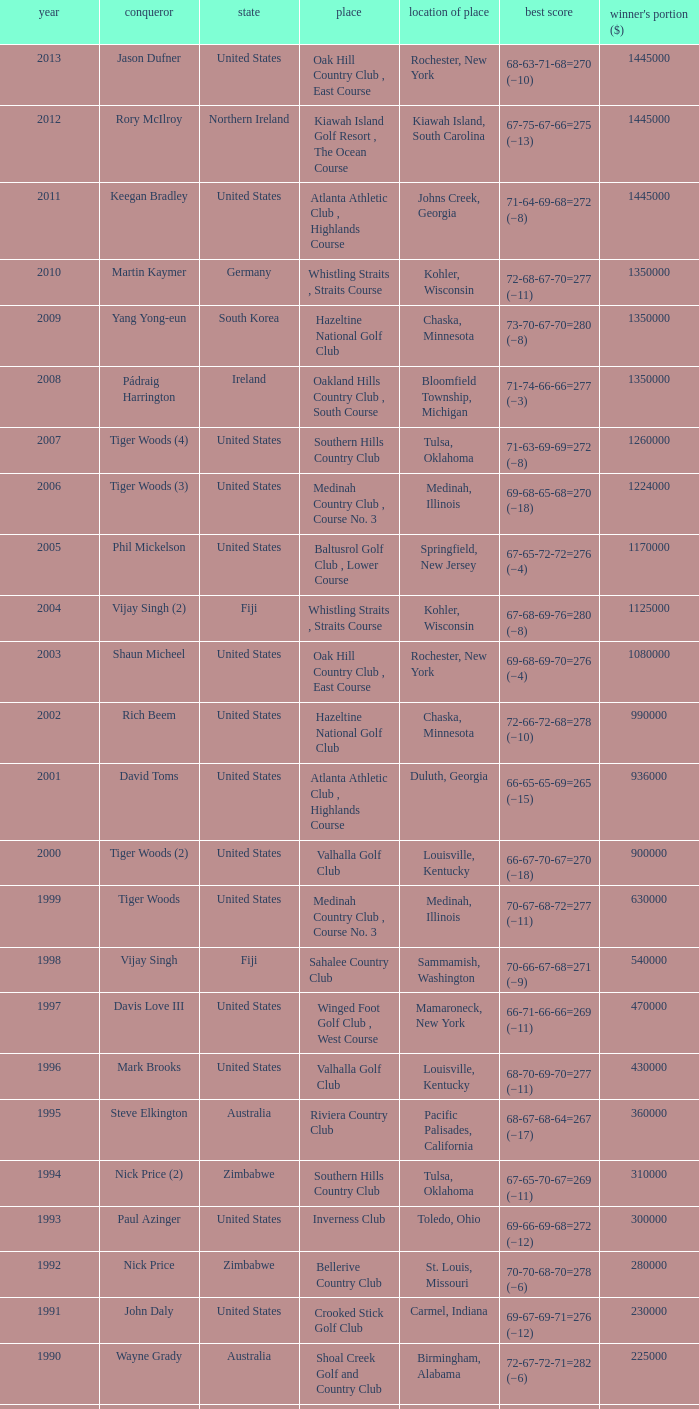List all winning scores from 1982. 63-69-68-72=272 (−8). 